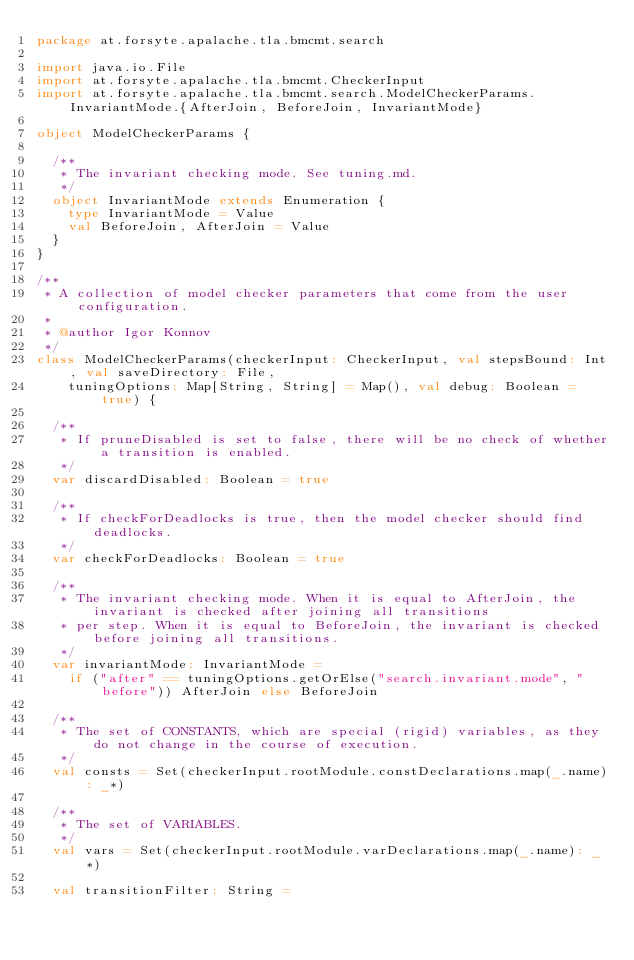Convert code to text. <code><loc_0><loc_0><loc_500><loc_500><_Scala_>package at.forsyte.apalache.tla.bmcmt.search

import java.io.File
import at.forsyte.apalache.tla.bmcmt.CheckerInput
import at.forsyte.apalache.tla.bmcmt.search.ModelCheckerParams.InvariantMode.{AfterJoin, BeforeJoin, InvariantMode}

object ModelCheckerParams {

  /**
   * The invariant checking mode. See tuning.md.
   */
  object InvariantMode extends Enumeration {
    type InvariantMode = Value
    val BeforeJoin, AfterJoin = Value
  }
}

/**
 * A collection of model checker parameters that come from the user configuration.
 *
 * @author Igor Konnov
 */
class ModelCheckerParams(checkerInput: CheckerInput, val stepsBound: Int, val saveDirectory: File,
    tuningOptions: Map[String, String] = Map(), val debug: Boolean = true) {

  /**
   * If pruneDisabled is set to false, there will be no check of whether a transition is enabled.
   */
  var discardDisabled: Boolean = true

  /**
   * If checkForDeadlocks is true, then the model checker should find deadlocks.
   */
  var checkForDeadlocks: Boolean = true

  /**
   * The invariant checking mode. When it is equal to AfterJoin, the invariant is checked after joining all transitions
   * per step. When it is equal to BeforeJoin, the invariant is checked before joining all transitions.
   */
  var invariantMode: InvariantMode =
    if ("after" == tuningOptions.getOrElse("search.invariant.mode", "before")) AfterJoin else BeforeJoin

  /**
   * The set of CONSTANTS, which are special (rigid) variables, as they do not change in the course of execution.
   */
  val consts = Set(checkerInput.rootModule.constDeclarations.map(_.name): _*)

  /**
   * The set of VARIABLES.
   */
  val vars = Set(checkerInput.rootModule.varDeclarations.map(_.name): _*)

  val transitionFilter: String =</code> 